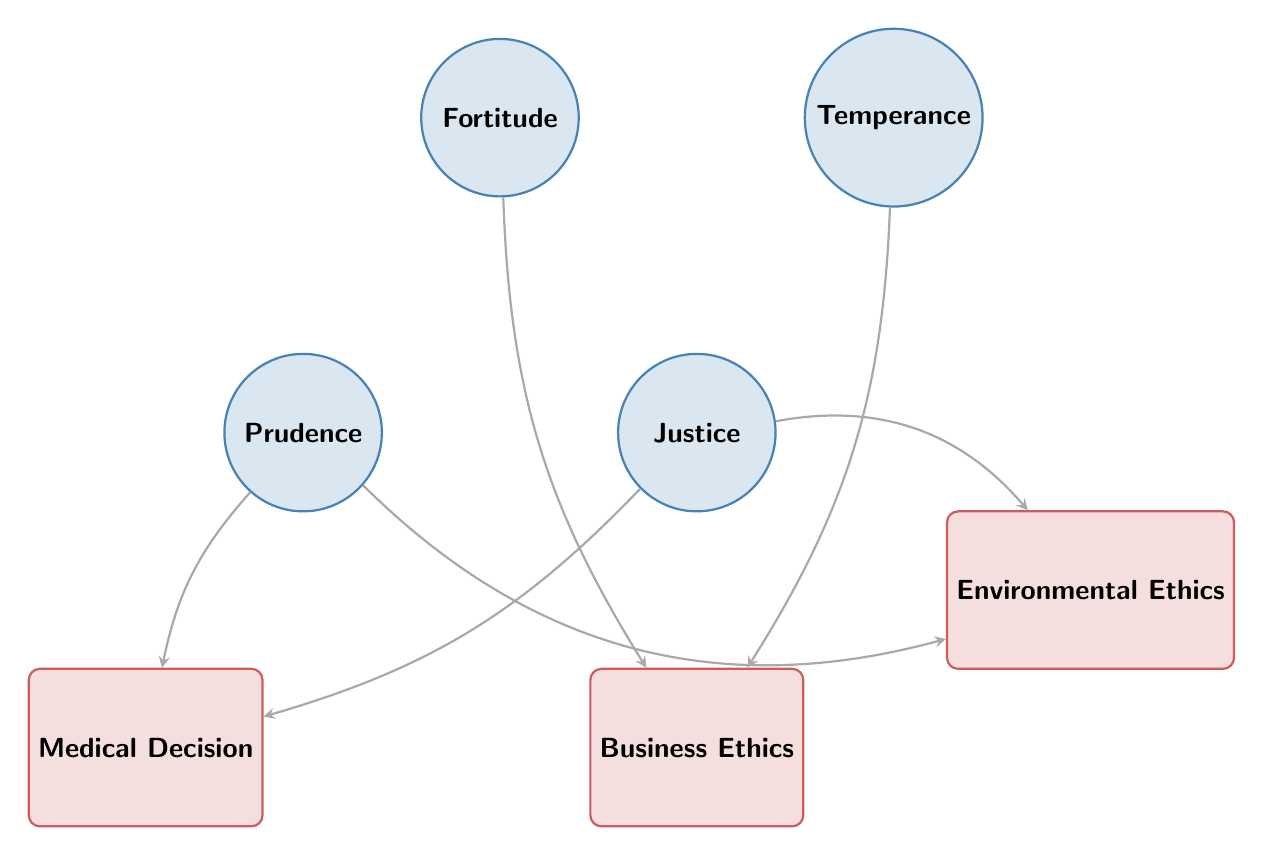What are the moral virtues listed in the diagram? The diagram presents four distinct moral virtues: Prudence, Justice, Fortitude, and Temperance. These are the nodes categorized under "Moral Virtues."
Answer: Prudence, Justice, Fortitude, Temperance How many ethical dilemmas are represented? The diagram contains three nodes categorized as "Ethical Dilemmas," which are Medical Decision, Business Ethics, and Environmental Ethics. Counting these nodes gives a total of three.
Answer: 3 Which moral virtue is linked to Medical Decision? The diagram shows two arrows pointing to Medical Decision: one from Prudence and another from Justice, indicating both virtues are linked to this ethical dilemma.
Answer: Prudence, Justice How many total links are present in the diagram? The diagram includes six distinct links that connect moral virtues to ethical dilemmas. Counting each individual link provides the total number: one from Prudence to Medical Decision, one from Justice to Medical Decision, one from Fortitude to Business Ethics, one from Temperance to Business Ethics, one from Prudence to Environmental Ethics, and one from Justice to Environmental Ethics.
Answer: 6 Which moral virtues are associated with Business Ethics? The diagram illustrates two connections to Business Ethics: one from Fortitude and another from Temperance. Both of these moral virtues are linked to the ethical dilemma in question.
Answer: Fortitude, Temperance If a decision involves Environmental Ethics, which moral virtues might guide that decision? The diagram reveals that both Prudence and Justice are linked to Environmental Ethics. Therefore, these two moral virtues would potentially guide decisions in this ethical dilemma.
Answer: Prudence, Justice How does the moral virtue of Fortitude influence ethical business decisions? According to the diagram, Fortitude is linked to Business Ethics, indicating that this virtue may provide the necessary courage and resilience to uphold ethical standards in business practices. The connection suggests that decisions made in a business context are influenced by the character-driven virtue of Fortitude.
Answer: Courage, resilience What is the relationship between Justice and the Medical Decision? The diagram shows an arrow linking Justice to Medical Decision, indicating that Justice plays a role in guiding ethical decisions related to healthcare and medical practices. This signifies that considerations of fairness and equity should be incorporated when making medical decisions.
Answer: Fairness, equity 